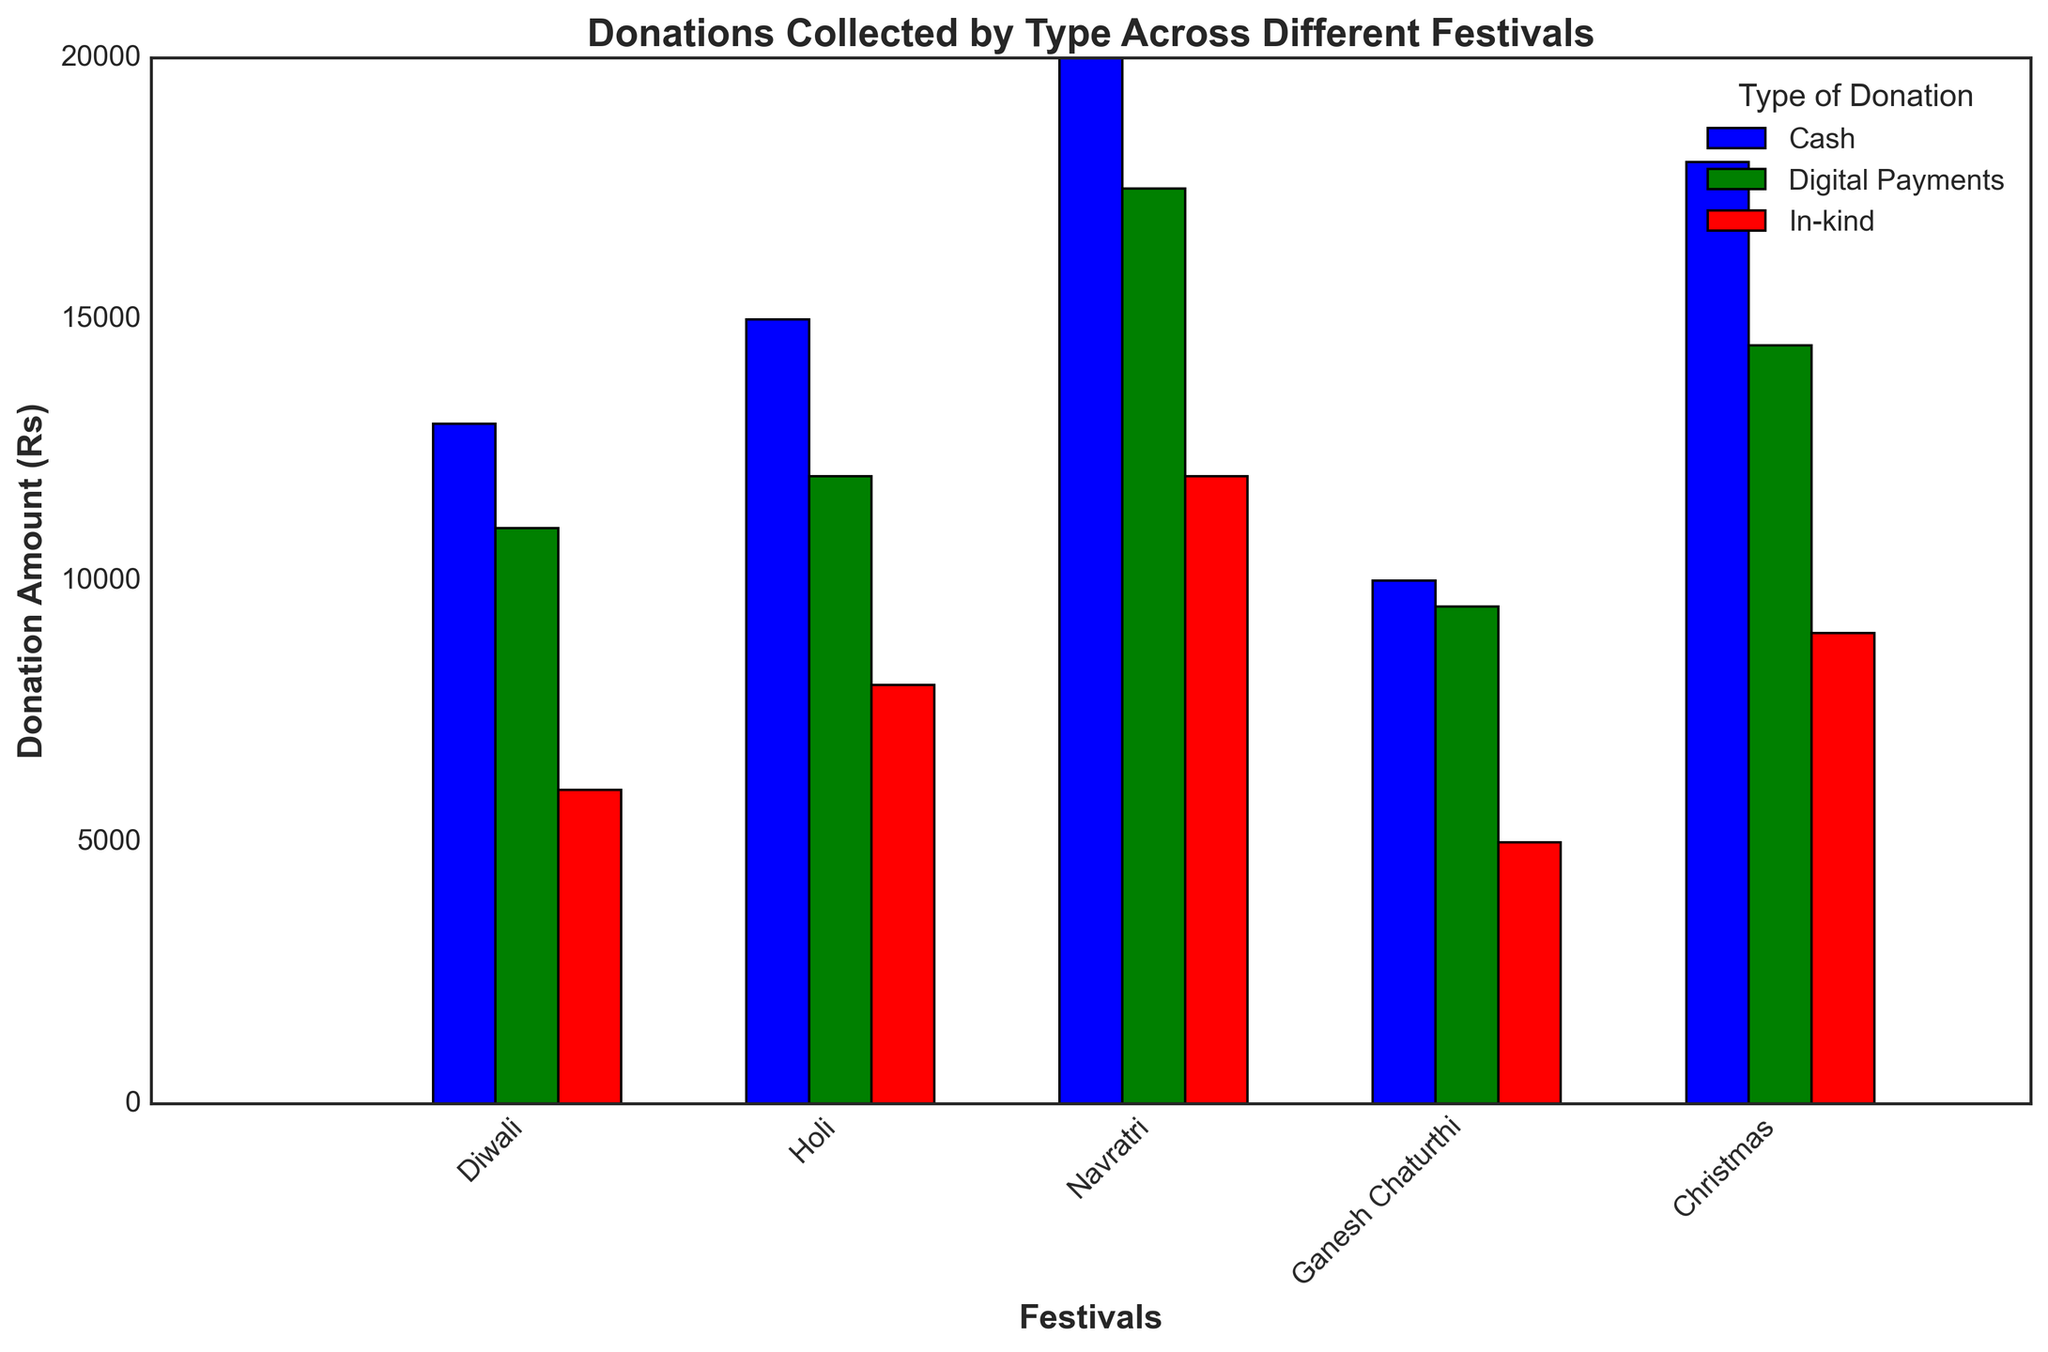Which type of donation collected the highest amount during Ganesh Chaturthi? To determine which type of donation collected the highest amount during Ganesh Chaturthi, we look at the tallest bar in the Ganesh Chaturthi category. The bars for Ganesh Chaturthi are: Cash (20,000), Digital Payments (17,500), and In-kind (12,000). The highest is Cash at 20,000.
Answer: Cash Which festival collected the most in-kind donations? We compare the heights of the In-kind donation bars across all festivals. The values are Diwali (8,000), Holi (5,000), Navratri (9,000), Ganesh Chaturthi (12,000), and Christmas (6,000). The highest is Ganesh Chaturthi with 12,000.
Answer: Ganesh Chaturthi During which festival were digital payments the least? To find when digital payments were the least, we look at the shortest Digital Payments bar. The values are Diwali (12,000), Holi (9,500), Navratri (14,500), Ganesh Chaturthi (17,500), and Christmas (11,000). The least amount is Holi with 9,500.
Answer: Holi How much more cash was collected during Navratri compared to Christmas? To find out how much more cash was collected during Navratri compared to Christmas, we subtract the Christmas cash amount from the Navratri cash amount. Navratri collected 18,000 and Christmas collected 13,000. So, 18,000 - 13,000 = 5,000.
Answer: 5,000 What is the total amount collected from all types of donations during Diwali? To find the total amount collected during Diwali, we sum the amounts from Cash, Digital Payments, and In-kind. The amounts are Cash (15,000), Digital Payments (12,000), and In-kind (8,000). The total is 15,000 + 12,000 + 8,000 = 35,000.
Answer: 35,000 Which type of donation consistently has the lowest amount across all festivals? By comparing the three types (Cash, Digital Payments, In-kind) for each festival, we notice that In-kind donations are consistently lower than Cash and Digital Payments for Diwali (8,000), Holi (5,000), Navratri (9,000), Ganesh Chaturthi (12,000), and Christmas (6,000).
Answer: In-kind What is the average donation amount for Digital Payments across all festivals? To find the average amount for Digital Payments, we sum the Digital Payments amounts across all festivals and then divide by the number of festivals. The amounts are 12,000 (Diwali) + 9,500 (Holi) + 14,500 (Navratri) + 17,500 (Ganesh Chaturthi) + 11,000 (Christmas). The sum is 64,500. There are 5 festivals, so the average is 64,500 / 5 = 12,900.
Answer: 12,900 